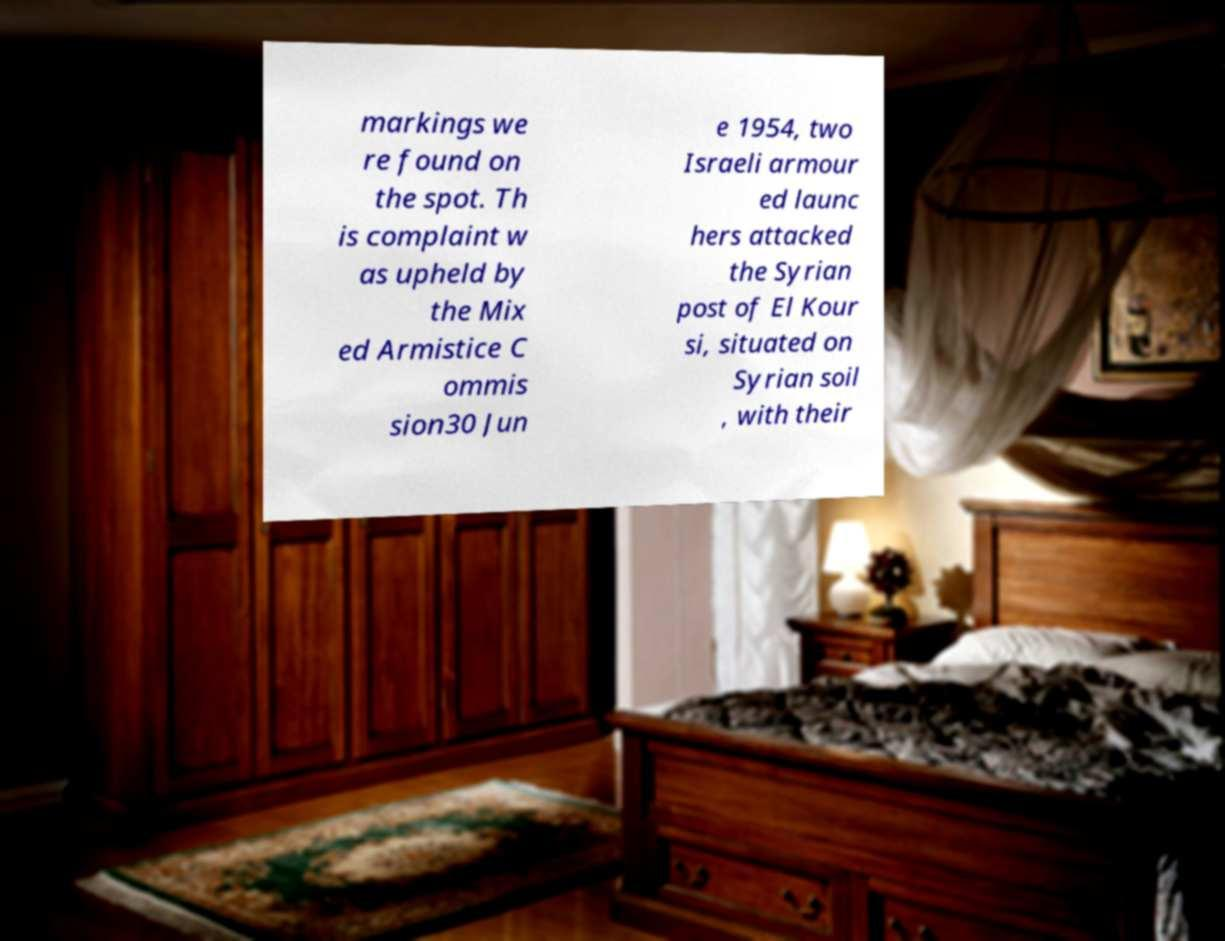I need the written content from this picture converted into text. Can you do that? markings we re found on the spot. Th is complaint w as upheld by the Mix ed Armistice C ommis sion30 Jun e 1954, two Israeli armour ed launc hers attacked the Syrian post of El Kour si, situated on Syrian soil , with their 